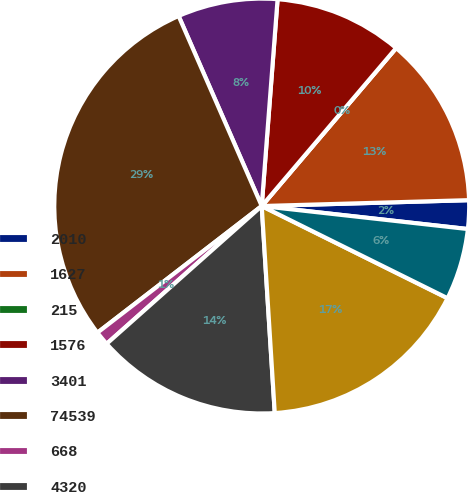Convert chart. <chart><loc_0><loc_0><loc_500><loc_500><pie_chart><fcel>2010<fcel>1627<fcel>215<fcel>1576<fcel>3401<fcel>74539<fcel>668<fcel>4320<fcel>3039<fcel>1595<nl><fcel>2.22%<fcel>13.33%<fcel>0.0%<fcel>10.0%<fcel>7.78%<fcel>28.89%<fcel>1.11%<fcel>14.44%<fcel>16.67%<fcel>5.56%<nl></chart> 